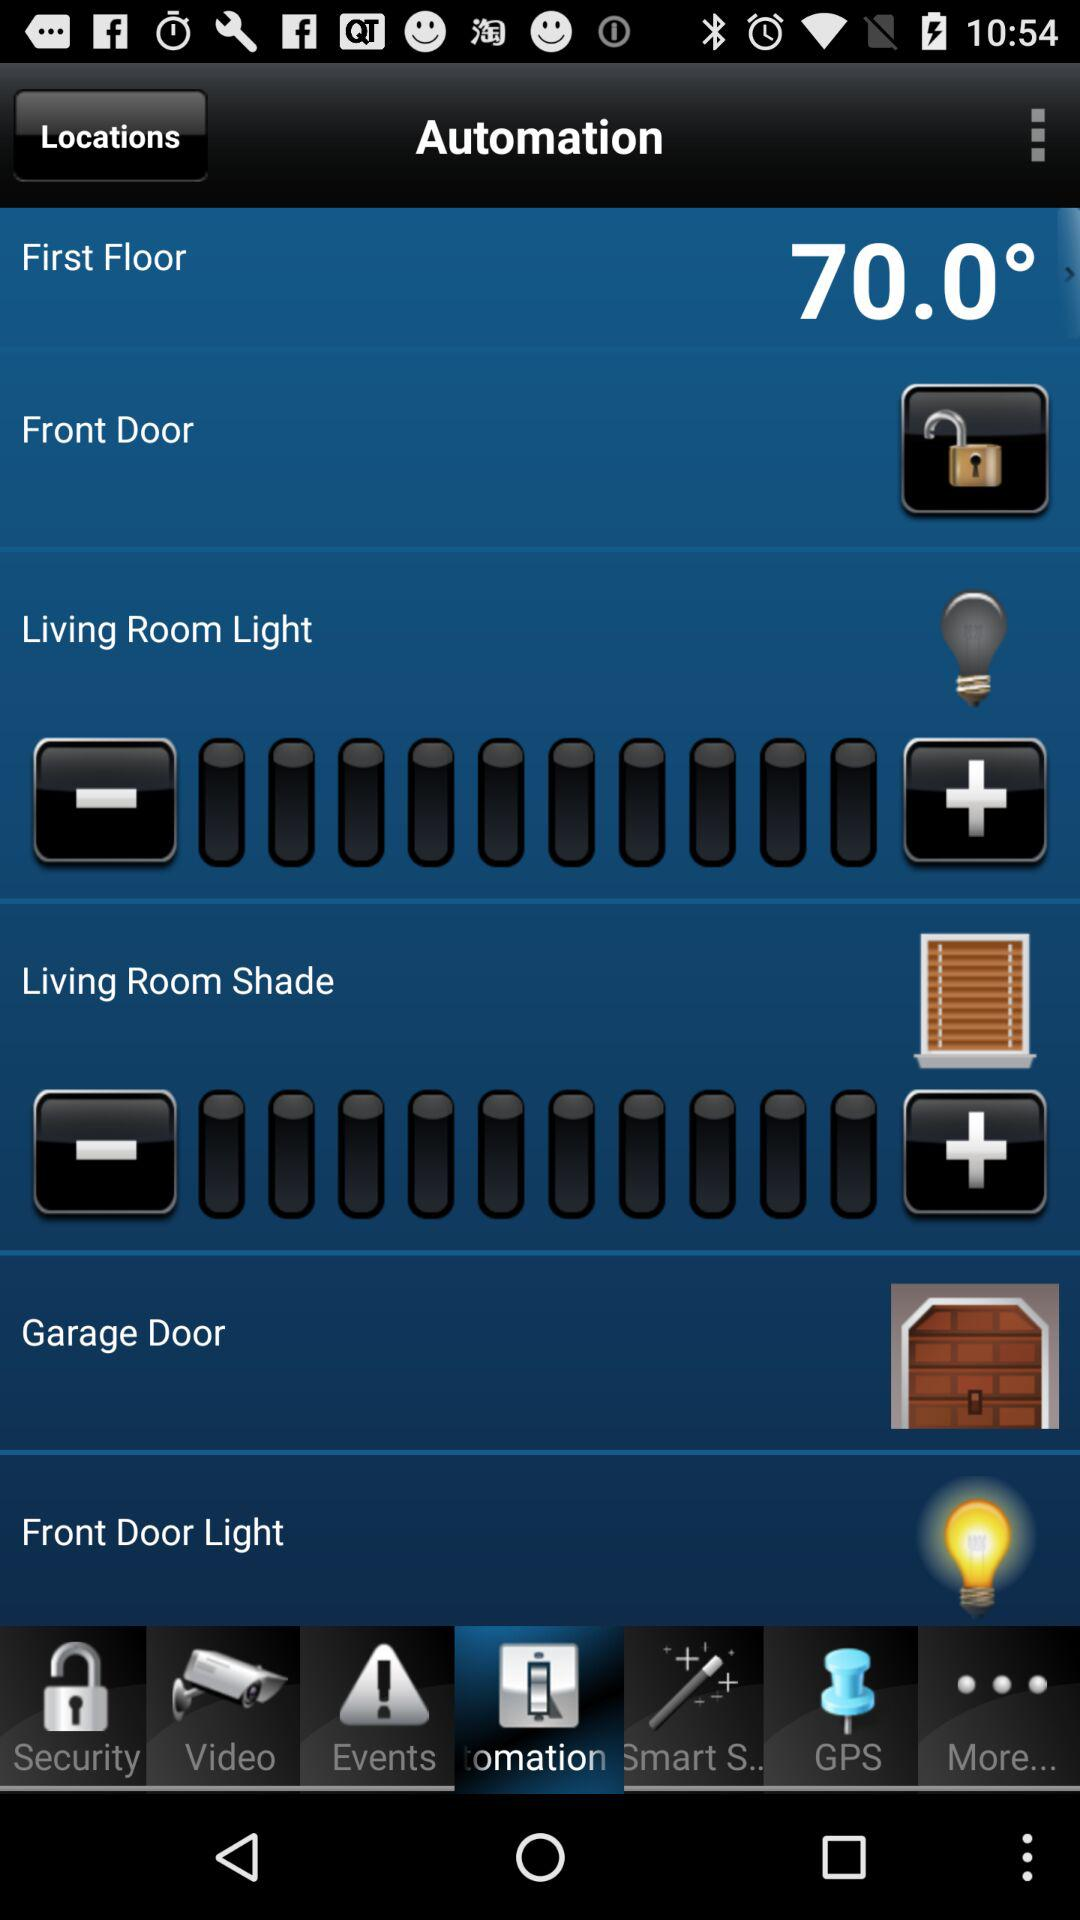Which tab is selected? The selected tab is "Automation". 